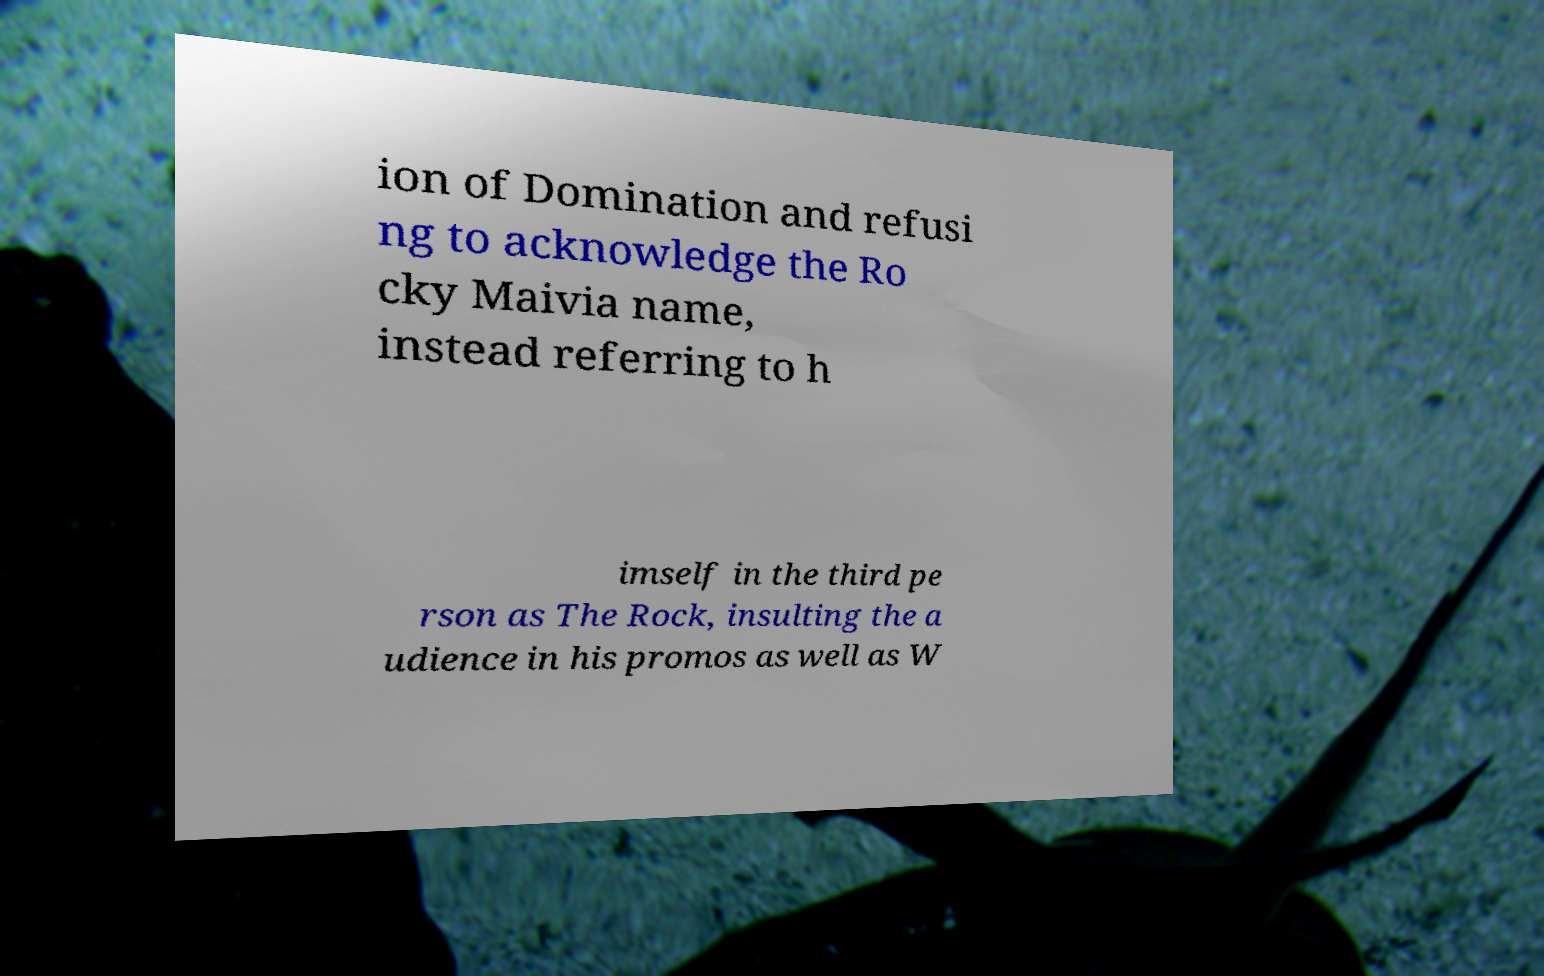I need the written content from this picture converted into text. Can you do that? ion of Domination and refusi ng to acknowledge the Ro cky Maivia name, instead referring to h imself in the third pe rson as The Rock, insulting the a udience in his promos as well as W 